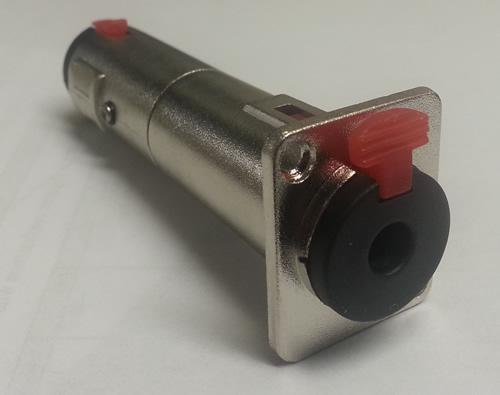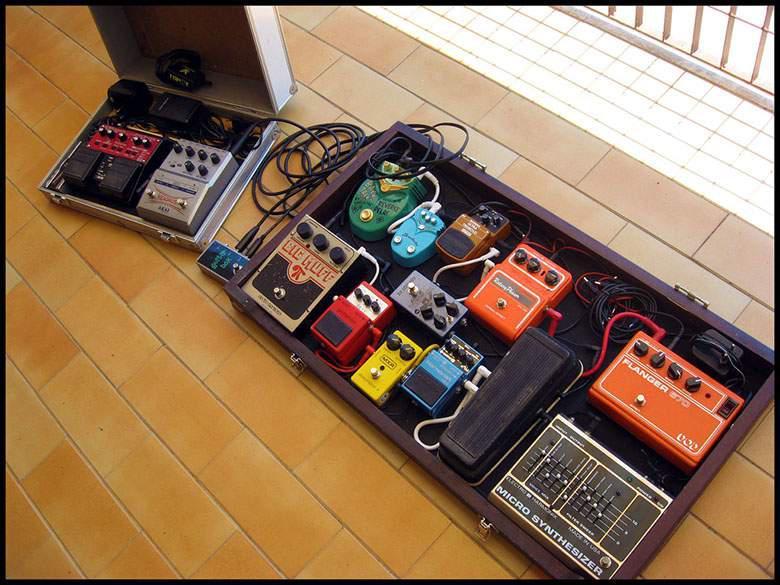The first image is the image on the left, the second image is the image on the right. Examine the images to the left and right. Is the description "Both items are sitting on wood planks." accurate? Answer yes or no. No. The first image is the image on the left, the second image is the image on the right. Analyze the images presented: Is the assertion "The left and right image contains the same number of orange rectangle blocks with three white dots." valid? Answer yes or no. No. 